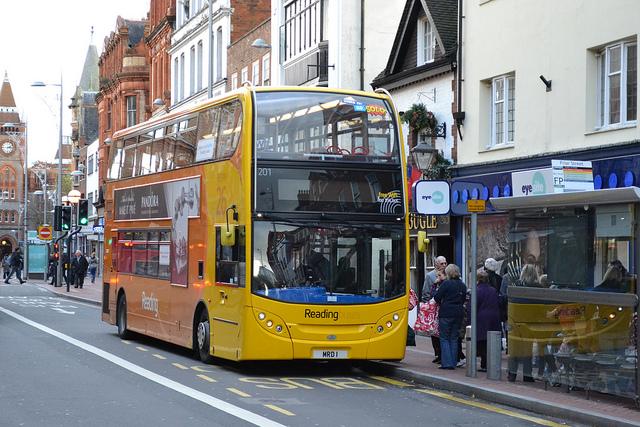Is it possible to determine the season this photo was taken in?
Keep it brief. Yes. Is there a clock in the picture?
Give a very brief answer. Yes. What is written on the front of the bus?
Be succinct. Reading. 